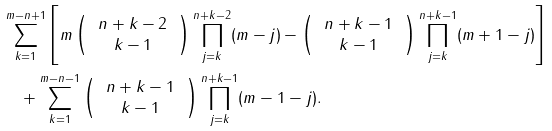<formula> <loc_0><loc_0><loc_500><loc_500>& \sum _ { k = 1 } ^ { m - n + 1 } \left [ m \left ( \, \begin{array} c n + k - 2 \\ k - 1 \end{array} \, \right ) \prod _ { j = k } ^ { n + k - 2 } ( m - j ) - \left ( \, \begin{array} c n + k - 1 \\ k - 1 \end{array} \, \right ) \prod _ { j = k } ^ { n + k - 1 } ( m + 1 - j ) \right ] \\ & \quad + \sum _ { k = 1 } ^ { m - n - 1 } \left ( \, \begin{array} c n + k - 1 \\ k - 1 \end{array} \, \right ) \prod _ { j = k } ^ { n + k - 1 } ( m - 1 - j ) .</formula> 